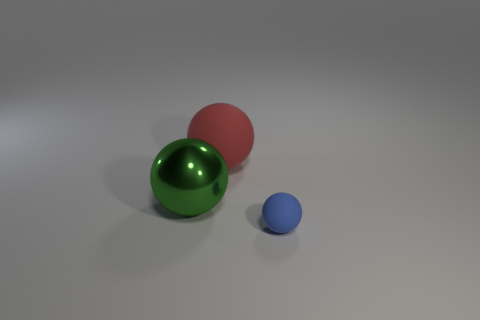Subtract all cyan spheres. Subtract all green cylinders. How many spheres are left? 3 Add 2 big yellow metal cylinders. How many objects exist? 5 Subtract all tiny gray rubber blocks. Subtract all red spheres. How many objects are left? 2 Add 3 big green shiny balls. How many big green shiny balls are left? 4 Add 1 green objects. How many green objects exist? 2 Subtract 0 blue blocks. How many objects are left? 3 